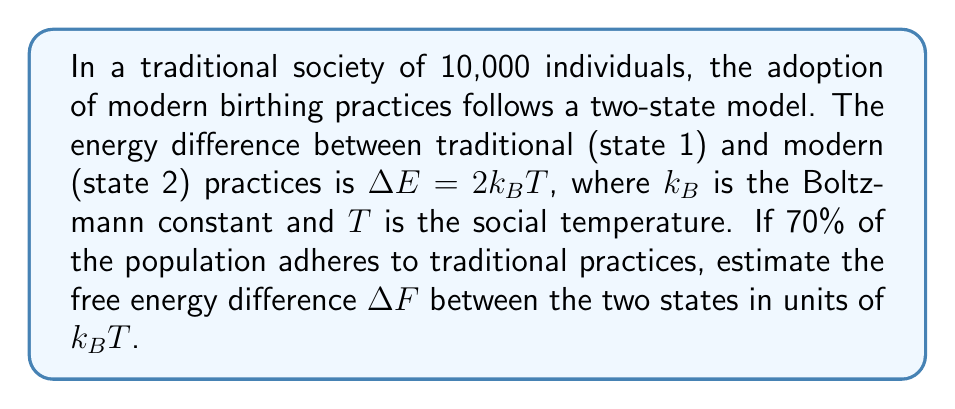Help me with this question. To solve this problem, we'll use concepts from statistical mechanics applied to social systems:

1) The partition function for a two-state system is:
   $$Z = e^{-\beta E_1} + e^{-\beta E_2}$$
   where $\beta = \frac{1}{k_BT}$

2) The probability of being in state 1 (traditional practices) is:
   $$p_1 = \frac{e^{-\beta E_1}}{Z} = 0.70$$

3) We can set $E_1 = 0$ as a reference point. Then $E_2 = \Delta E = 2k_BT$

4) Substituting into the partition function:
   $$Z = 1 + e^{-2}$$

5) Using $p_1 = \frac{1}{Z} = 0.70$, we can solve for $Z$:
   $$Z = \frac{1}{0.70} \approx 1.429$$

6) The free energy difference is given by:
   $$\Delta F = -k_BT \ln\left(\frac{Z_2}{Z_1}\right) = -k_BT \ln\left(\frac{e^{-2}}{1}\right) = 2k_BT - k_BT \ln(Z)$$

7) Substituting the value of $Z$:
   $$\Delta F = 2k_BT - k_BT \ln(1.429) \approx 1.643k_BT$$
Answer: $1.643k_BT$ 